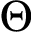Convert formula to latex. <formula><loc_0><loc_0><loc_500><loc_500>\Theta</formula> 